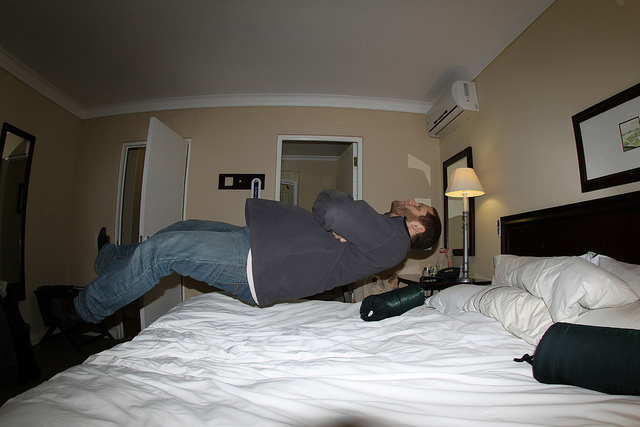The man here is posing to mimic what?
A. drunkenness
B. levitation
C. working out
D. insomnia
Answer with the option's letter from the given choices directly. B 